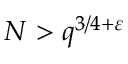Convert formula to latex. <formula><loc_0><loc_0><loc_500><loc_500>N > q ^ { 3 / 4 + \varepsilon }</formula> 